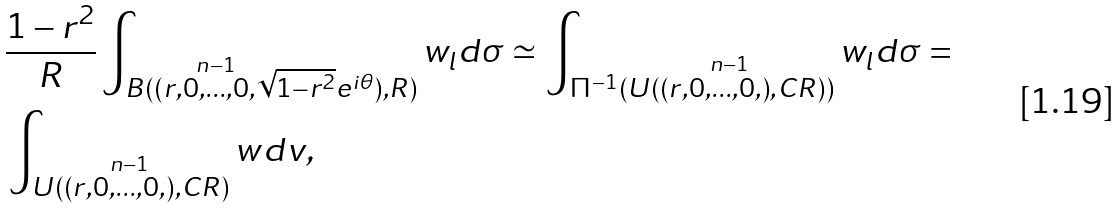<formula> <loc_0><loc_0><loc_500><loc_500>& \frac { 1 - r ^ { 2 } } { R } \int _ { B ( ( r , \stackrel { n - 1 } { 0 , \dots , 0 } , \sqrt { 1 - r ^ { 2 } } e ^ { i \theta } ) , R ) } w _ { l } d \sigma \simeq \int _ { \Pi ^ { - 1 } ( U ( ( r , \stackrel { n - 1 } { 0 , \dots , 0 , ) } , C R ) ) } w _ { l } d \sigma = \\ & \int _ { U ( ( r , \stackrel { n - 1 } { 0 , \dots , 0 , } ) , C R ) } w d v ,</formula> 